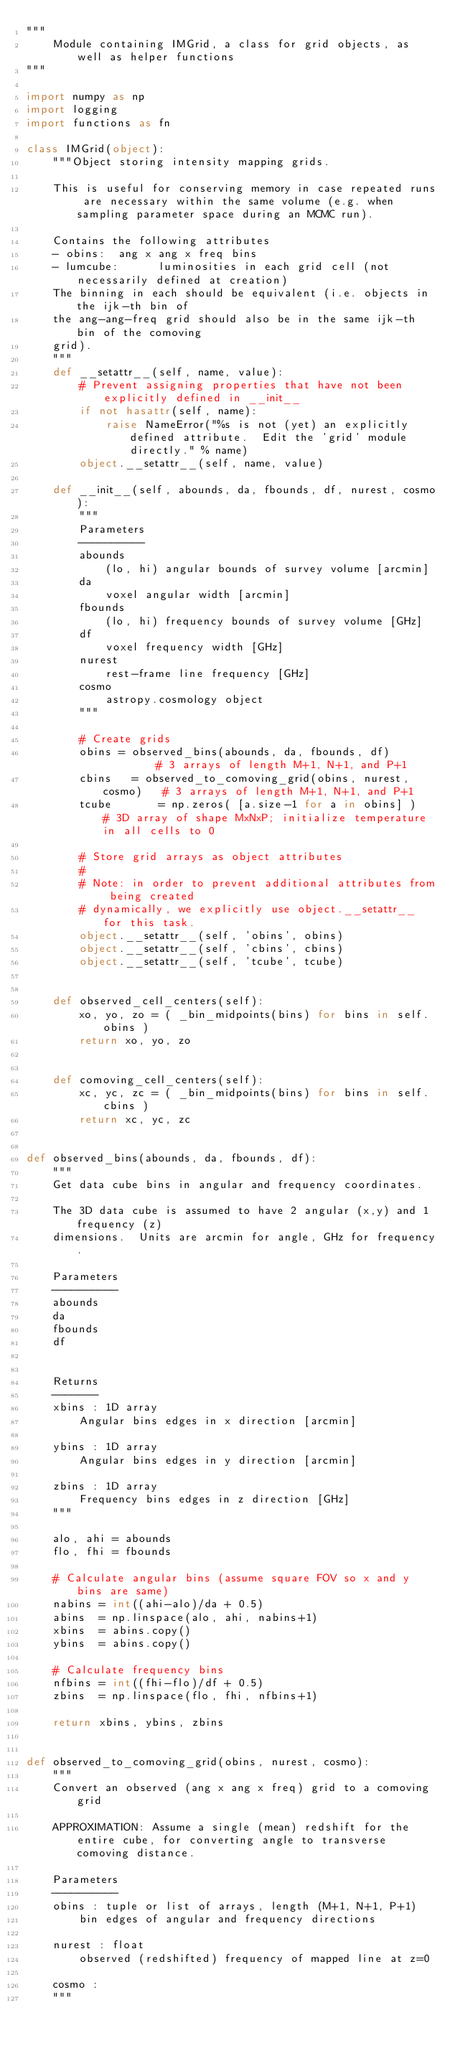Convert code to text. <code><loc_0><loc_0><loc_500><loc_500><_Python_>"""
    Module containing IMGrid, a class for grid objects, as well as helper functions
"""

import numpy as np
import logging
import functions as fn

class IMGrid(object):
    """Object storing intensity mapping grids.
    
    This is useful for conserving memory in case repeated runs are necessary within the same volume (e.g. when sampling parameter space during an MCMC run).

    Contains the following attributes
    - obins:  ang x ang x freq bins
    - lumcube:      luminosities in each grid cell (not necessarily defined at creation)
    The binning in each should be equivalent (i.e. objects in the ijk-th bin of
    the ang-ang-freq grid should also be in the same ijk-th bin of the comoving
    grid).
    """
    def __setattr__(self, name, value):
        # Prevent assigning properties that have not been explicitly defined in __init__
        if not hasattr(self, name):
            raise NameError("%s is not (yet) an explicitly defined attribute.  Edit the 'grid' module directly." % name)
        object.__setattr__(self, name, value)

    def __init__(self, abounds, da, fbounds, df, nurest, cosmo):
        """
        Parameters
        ----------
        abounds
            (lo, hi) angular bounds of survey volume [arcmin]
        da
            voxel angular width [arcmin]
        fbounds
            (lo, hi) frequency bounds of survey volume [GHz]
        df
            voxel frequency width [GHz]
        nurest
            rest-frame line frequency [GHz]
        cosmo
            astropy.cosmology object
        """

        # Create grids
        obins = observed_bins(abounds, da, fbounds, df)         # 3 arrays of length M+1, N+1, and P+1
        cbins   = observed_to_comoving_grid(obins, nurest, cosmo)   # 3 arrays of length M+1, N+1, and P+1
        tcube       = np.zeros( [a.size-1 for a in obins] )   # 3D array of shape MxNxP; initialize temperature in all cells to 0

        # Store grid arrays as object attributes
        # 
        # Note: in order to prevent additional attributes from being created
        # dynamically, we explicitly use object.__setattr__ for this task.
        object.__setattr__(self, 'obins', obins)
        object.__setattr__(self, 'cbins', cbins)
        object.__setattr__(self, 'tcube', tcube)


    def observed_cell_centers(self):
        xo, yo, zo = ( _bin_midpoints(bins) for bins in self.obins )
        return xo, yo, zo


    def comoving_cell_centers(self):
        xc, yc, zc = ( _bin_midpoints(bins) for bins in self.cbins )
        return xc, yc, zc


def observed_bins(abounds, da, fbounds, df):
    """
    Get data cube bins in angular and frequency coordinates.

    The 3D data cube is assumed to have 2 angular (x,y) and 1 frequency (z)
    dimensions.  Units are arcmin for angle, GHz for frequency.

    Parameters
    ----------
    abounds
    da
    fbounds
    df


    Returns
    -------
    xbins : 1D array
        Angular bins edges in x direction [arcmin]

    ybins : 1D array
        Angular bins edges in y direction [arcmin]

    zbins : 1D array
        Frequency bins edges in z direction [GHz]
    """

    alo, ahi = abounds
    flo, fhi = fbounds

    # Calculate angular bins (assume square FOV so x and y bins are same)
    nabins = int((ahi-alo)/da + 0.5)
    abins  = np.linspace(alo, ahi, nabins+1)
    xbins  = abins.copy()
    ybins  = abins.copy()

    # Calculate frequency bins
    nfbins = int((fhi-flo)/df + 0.5)
    zbins  = np.linspace(flo, fhi, nfbins+1)

    return xbins, ybins, zbins 


def observed_to_comoving_grid(obins, nurest, cosmo):
    """
    Convert an observed (ang x ang x freq) grid to a comoving grid

    APPROXIMATION: Assume a single (mean) redshift for the entire cube, for converting angle to transverse comoving distance.

    Parameters
    ----------
    obins : tuple or list of arrays, length (M+1, N+1, P+1)
        bin edges of angular and frequency directions

    nurest : float
        observed (redshifted) frequency of mapped line at z=0

    cosmo : 
    """
    </code> 